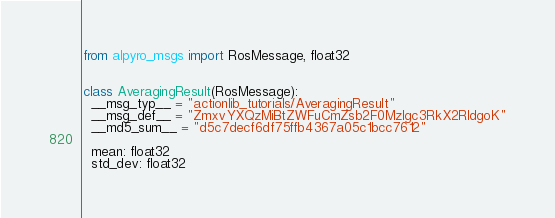Convert code to text. <code><loc_0><loc_0><loc_500><loc_500><_Python_>from alpyro_msgs import RosMessage, float32


class AveragingResult(RosMessage):
  __msg_typ__ = "actionlib_tutorials/AveragingResult"
  __msg_def__ = "ZmxvYXQzMiBtZWFuCmZsb2F0MzIgc3RkX2RldgoK"
  __md5_sum__ = "d5c7decf6df75ffb4367a05c1bcc7612"

  mean: float32
  std_dev: float32
</code> 